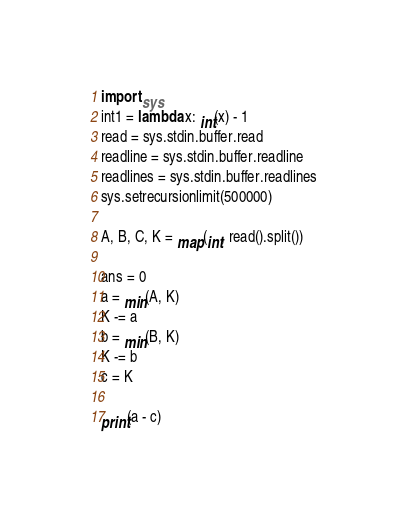<code> <loc_0><loc_0><loc_500><loc_500><_Python_>import sys
int1 = lambda x: int(x) - 1
read = sys.stdin.buffer.read
readline = sys.stdin.buffer.readline
readlines = sys.stdin.buffer.readlines
sys.setrecursionlimit(500000)

A, B, C, K = map(int, read().split())

ans = 0
a = min(A, K)
K -= a
b = min(B, K)
K -= b
c = K

print(a - c)
</code> 